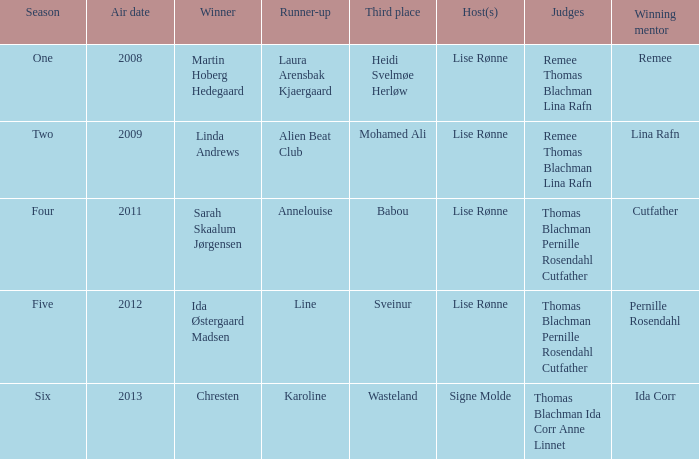Who was the winning mentor in season two? Lina Rafn. 